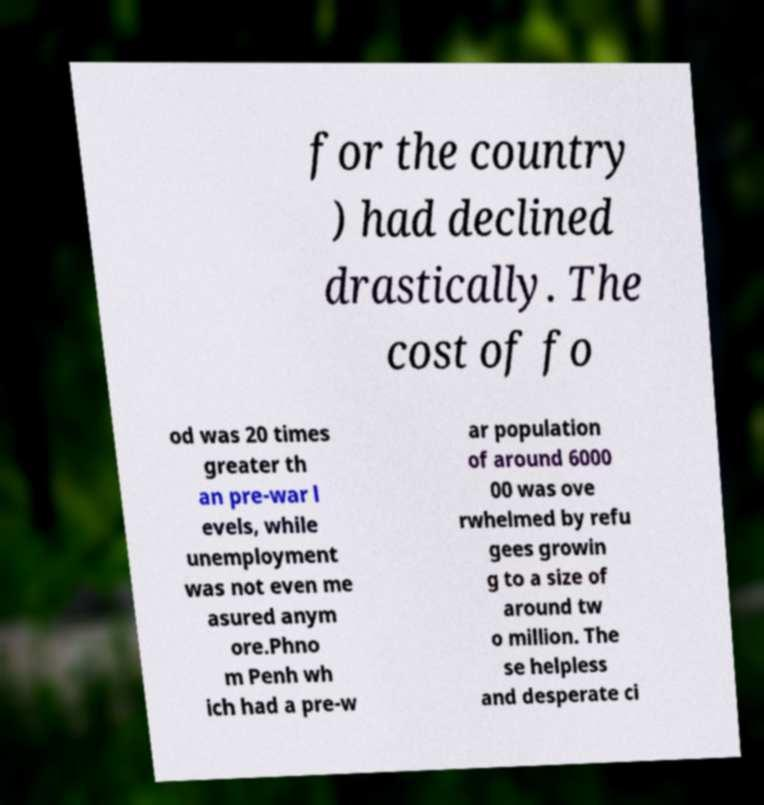What messages or text are displayed in this image? I need them in a readable, typed format. for the country ) had declined drastically. The cost of fo od was 20 times greater th an pre-war l evels, while unemployment was not even me asured anym ore.Phno m Penh wh ich had a pre-w ar population of around 6000 00 was ove rwhelmed by refu gees growin g to a size of around tw o million. The se helpless and desperate ci 